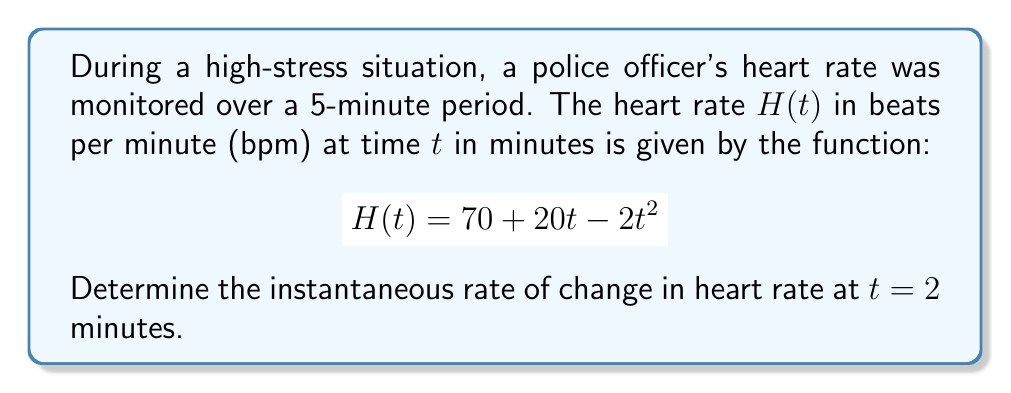Help me with this question. To find the instantaneous rate of change in heart rate at $t = 2$ minutes, we need to calculate the derivative of the heart rate function $H(t)$ and evaluate it at $t = 2$.

1. Given heart rate function:
   $$H(t) = 70 + 20t - 2t^2$$

2. Calculate the derivative $H'(t)$:
   $$H'(t) = \frac{d}{dt}(70 + 20t - 2t^2)$$
   $$H'(t) = 0 + 20 - 4t$$
   $$H'(t) = 20 - 4t$$

3. Evaluate $H'(t)$ at $t = 2$:
   $$H'(2) = 20 - 4(2)$$
   $$H'(2) = 20 - 8$$
   $$H'(2) = 12$$

The instantaneous rate of change at $t = 2$ minutes is 12 bpm per minute. This positive value indicates that the heart rate is increasing at this point in time, which is consistent with a high-stress situation.
Answer: The instantaneous rate of change in heart rate at $t = 2$ minutes is 12 beats per minute per minute (bpm/min). 